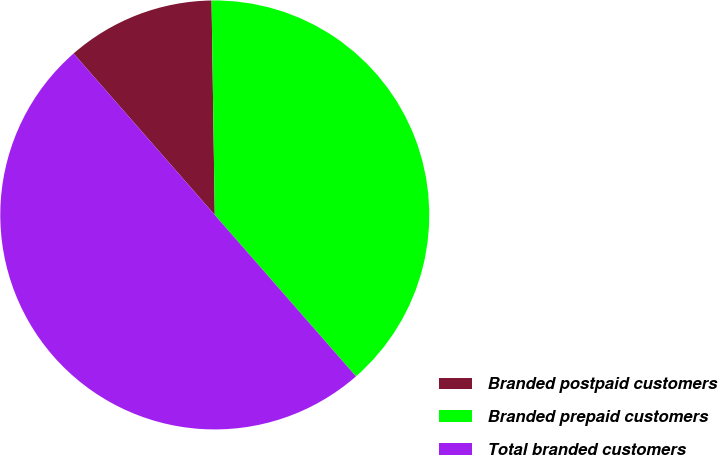Convert chart. <chart><loc_0><loc_0><loc_500><loc_500><pie_chart><fcel>Branded postpaid customers<fcel>Branded prepaid customers<fcel>Total branded customers<nl><fcel>11.2%<fcel>38.8%<fcel>50.0%<nl></chart> 